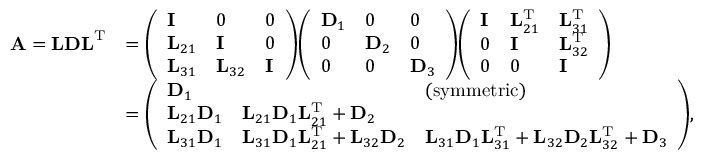<formula> <loc_0><loc_0><loc_500><loc_500>{ \begin{array} { r l } { A = L D L ^ { T } } & { = { \left ( \begin{array} { l l l } { I } & { 0 } & { 0 } \\ { L _ { 2 1 } } & { I } & { 0 } \\ { L _ { 3 1 } } & { L _ { 3 2 } } & { I } \end{array} \right ) } { \left ( \begin{array} { l l l } { D _ { 1 } } & { 0 } & { 0 } \\ { 0 } & { D _ { 2 } } & { 0 } \\ { 0 } & { 0 } & { D _ { 3 } } \end{array} \right ) } { \left ( \begin{array} { l l l } { I } & { L _ { 2 1 } ^ { T } } & { L _ { 3 1 } ^ { T } } \\ { 0 } & { I } & { L _ { 3 2 } ^ { T } } \\ { 0 } & { 0 } & { I } \end{array} \right ) } } \\ & { = { \left ( \begin{array} { l l l } { D _ { 1 } } & & { ( s y m m e t r i c ) } \\ { L _ { 2 1 } D _ { 1 } } & { L _ { 2 1 } D _ { 1 } L _ { 2 1 } ^ { T } + D _ { 2 } } & \\ { L _ { 3 1 } D _ { 1 } } & { L _ { 3 1 } D _ { 1 } L _ { 2 1 } ^ { T } + L _ { 3 2 } D _ { 2 } } & { L _ { 3 1 } D _ { 1 } L _ { 3 1 } ^ { T } + L _ { 3 2 } D _ { 2 } L _ { 3 2 } ^ { T } + D _ { 3 } } \end{array} \right ) } , } \end{array} }</formula> 